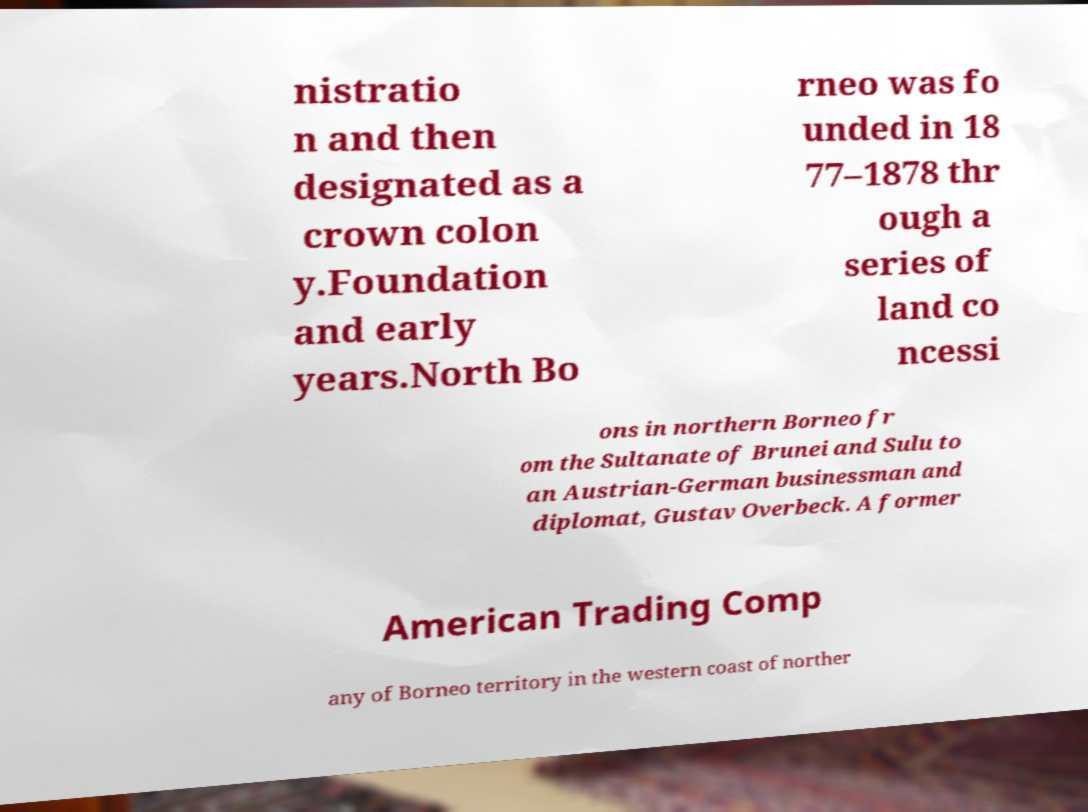Could you assist in decoding the text presented in this image and type it out clearly? nistratio n and then designated as a crown colon y.Foundation and early years.North Bo rneo was fo unded in 18 77–1878 thr ough a series of land co ncessi ons in northern Borneo fr om the Sultanate of Brunei and Sulu to an Austrian-German businessman and diplomat, Gustav Overbeck. A former American Trading Comp any of Borneo territory in the western coast of norther 